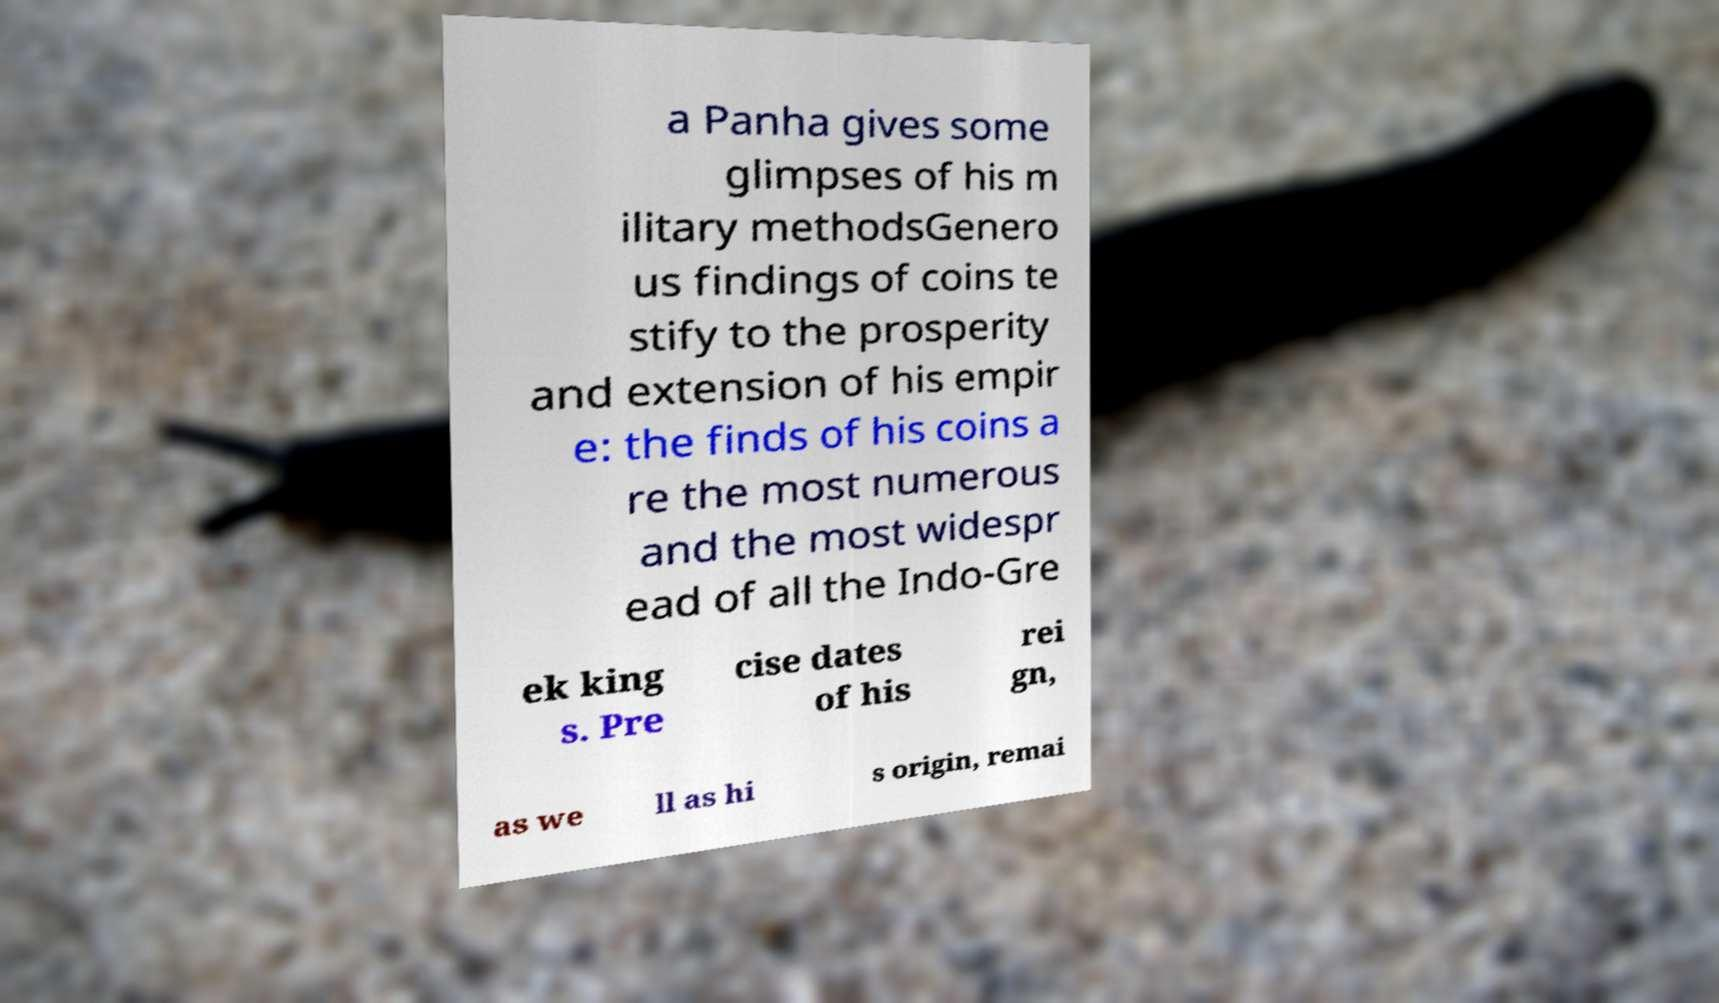Can you read and provide the text displayed in the image?This photo seems to have some interesting text. Can you extract and type it out for me? a Panha gives some glimpses of his m ilitary methodsGenero us findings of coins te stify to the prosperity and extension of his empir e: the finds of his coins a re the most numerous and the most widespr ead of all the Indo-Gre ek king s. Pre cise dates of his rei gn, as we ll as hi s origin, remai 